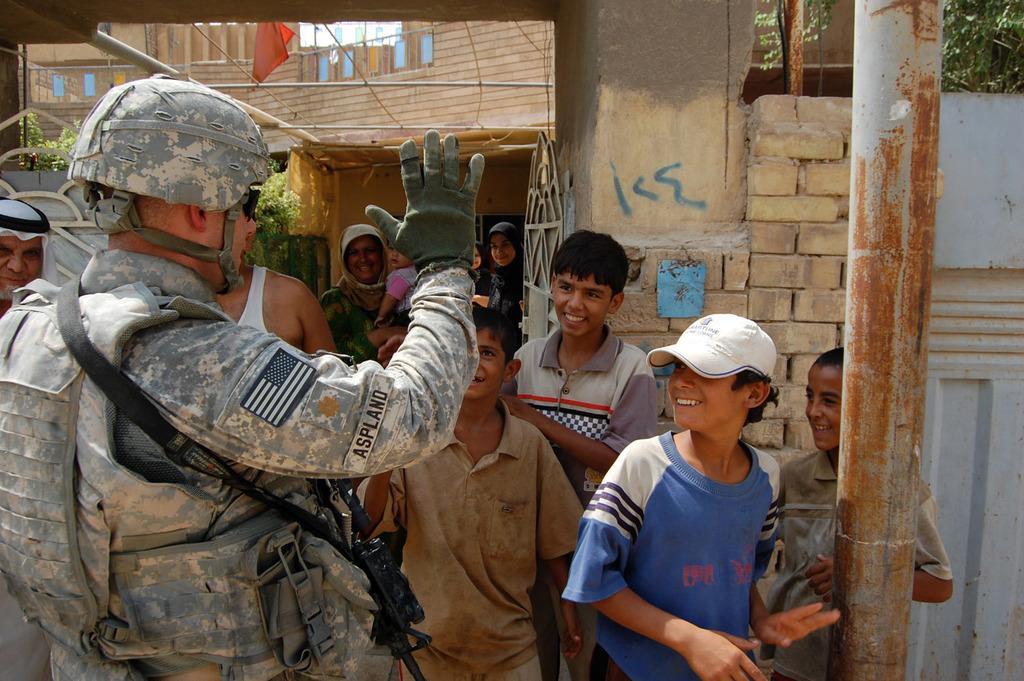Could you give a brief overview of what you see in this image? In this there are some people who are standing and some of them are smiling, in the background there are some houses, plants, wires and some flags. On the right side there is a pole. 